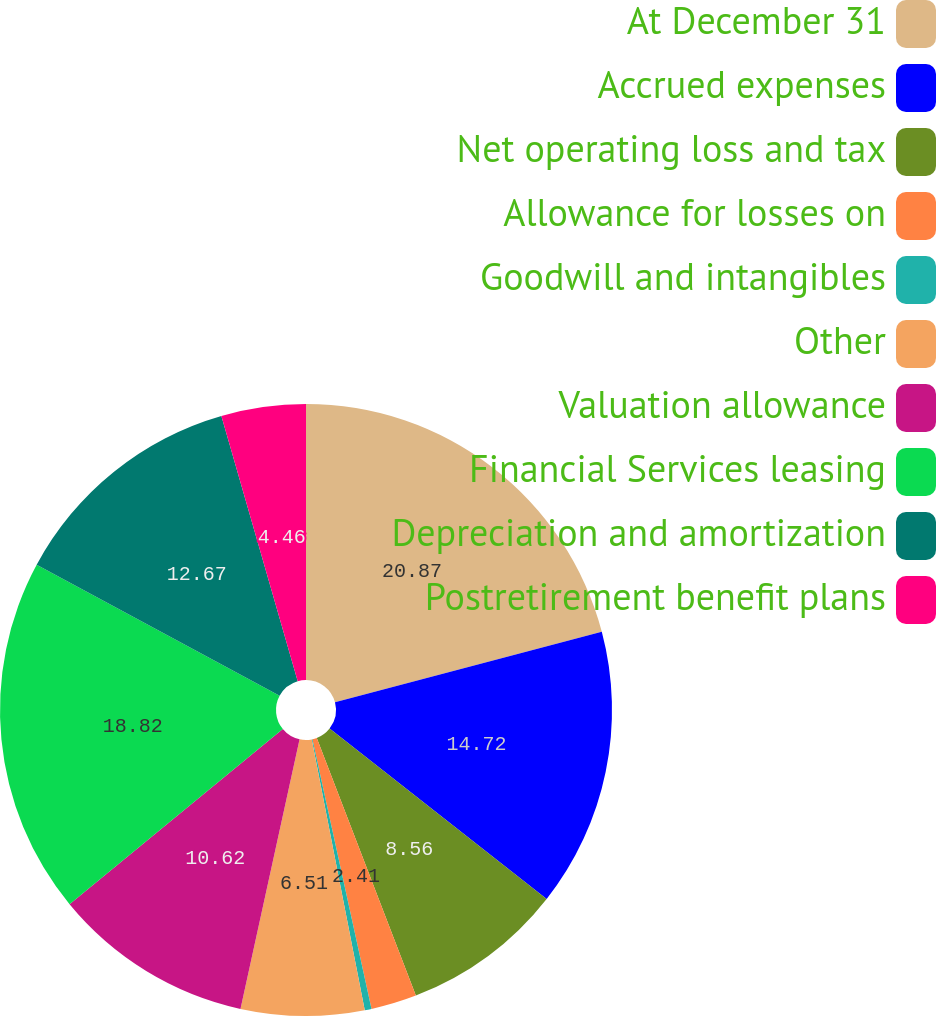Convert chart. <chart><loc_0><loc_0><loc_500><loc_500><pie_chart><fcel>At December 31<fcel>Accrued expenses<fcel>Net operating loss and tax<fcel>Allowance for losses on<fcel>Goodwill and intangibles<fcel>Other<fcel>Valuation allowance<fcel>Financial Services leasing<fcel>Depreciation and amortization<fcel>Postretirement benefit plans<nl><fcel>20.88%<fcel>14.72%<fcel>8.56%<fcel>2.41%<fcel>0.36%<fcel>6.51%<fcel>10.62%<fcel>18.82%<fcel>12.67%<fcel>4.46%<nl></chart> 